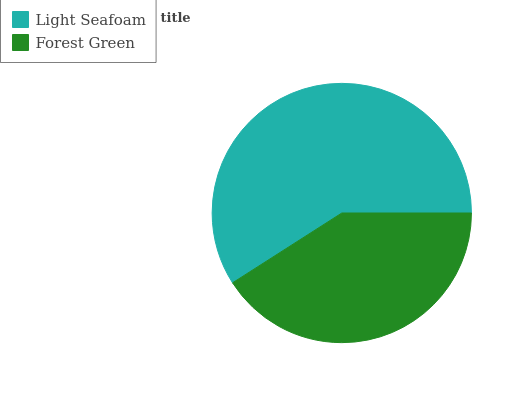Is Forest Green the minimum?
Answer yes or no. Yes. Is Light Seafoam the maximum?
Answer yes or no. Yes. Is Forest Green the maximum?
Answer yes or no. No. Is Light Seafoam greater than Forest Green?
Answer yes or no. Yes. Is Forest Green less than Light Seafoam?
Answer yes or no. Yes. Is Forest Green greater than Light Seafoam?
Answer yes or no. No. Is Light Seafoam less than Forest Green?
Answer yes or no. No. Is Light Seafoam the high median?
Answer yes or no. Yes. Is Forest Green the low median?
Answer yes or no. Yes. Is Forest Green the high median?
Answer yes or no. No. Is Light Seafoam the low median?
Answer yes or no. No. 